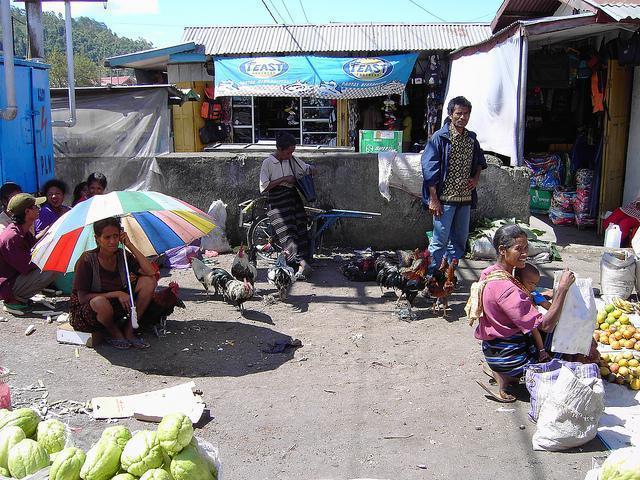How many people are there?
Give a very brief answer. 9. How many people are in the picture?
Give a very brief answer. 5. How many motorcycles are between the sidewalk and the yellow line in the road?
Give a very brief answer. 0. 